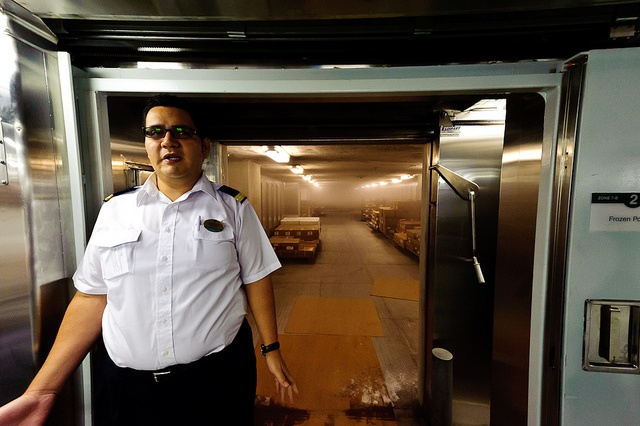Describe the objects in this image and their specific colors. I can see people in darkgray, lightgray, black, and maroon tones in this image. 